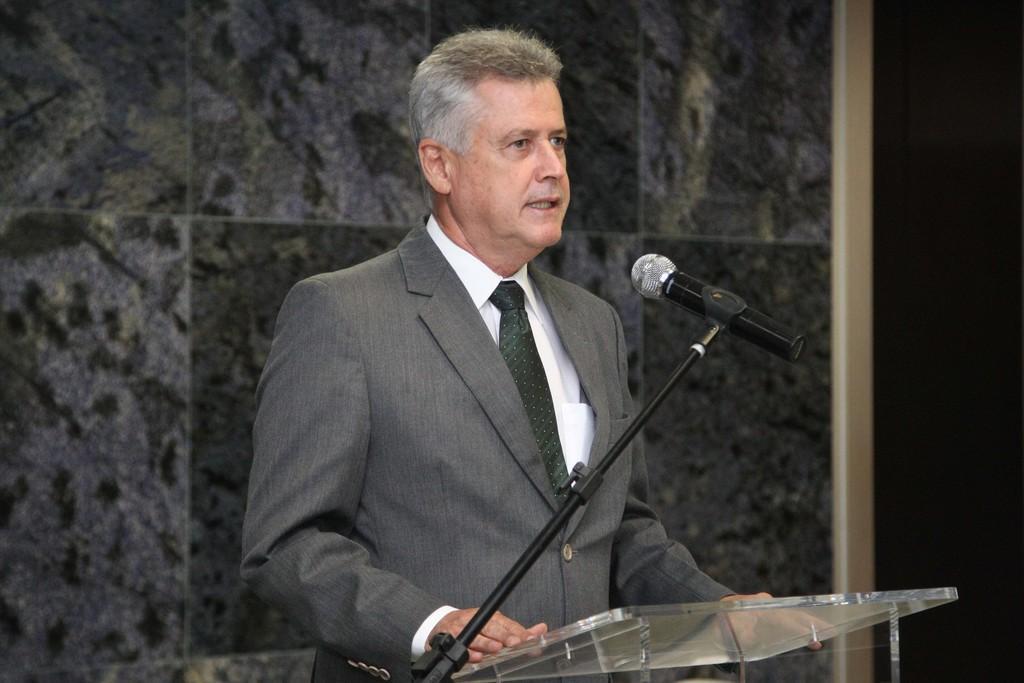Can you describe this image briefly? In this image there is a person standing in front of a podium and there is a mic, in the background there is a wall. 